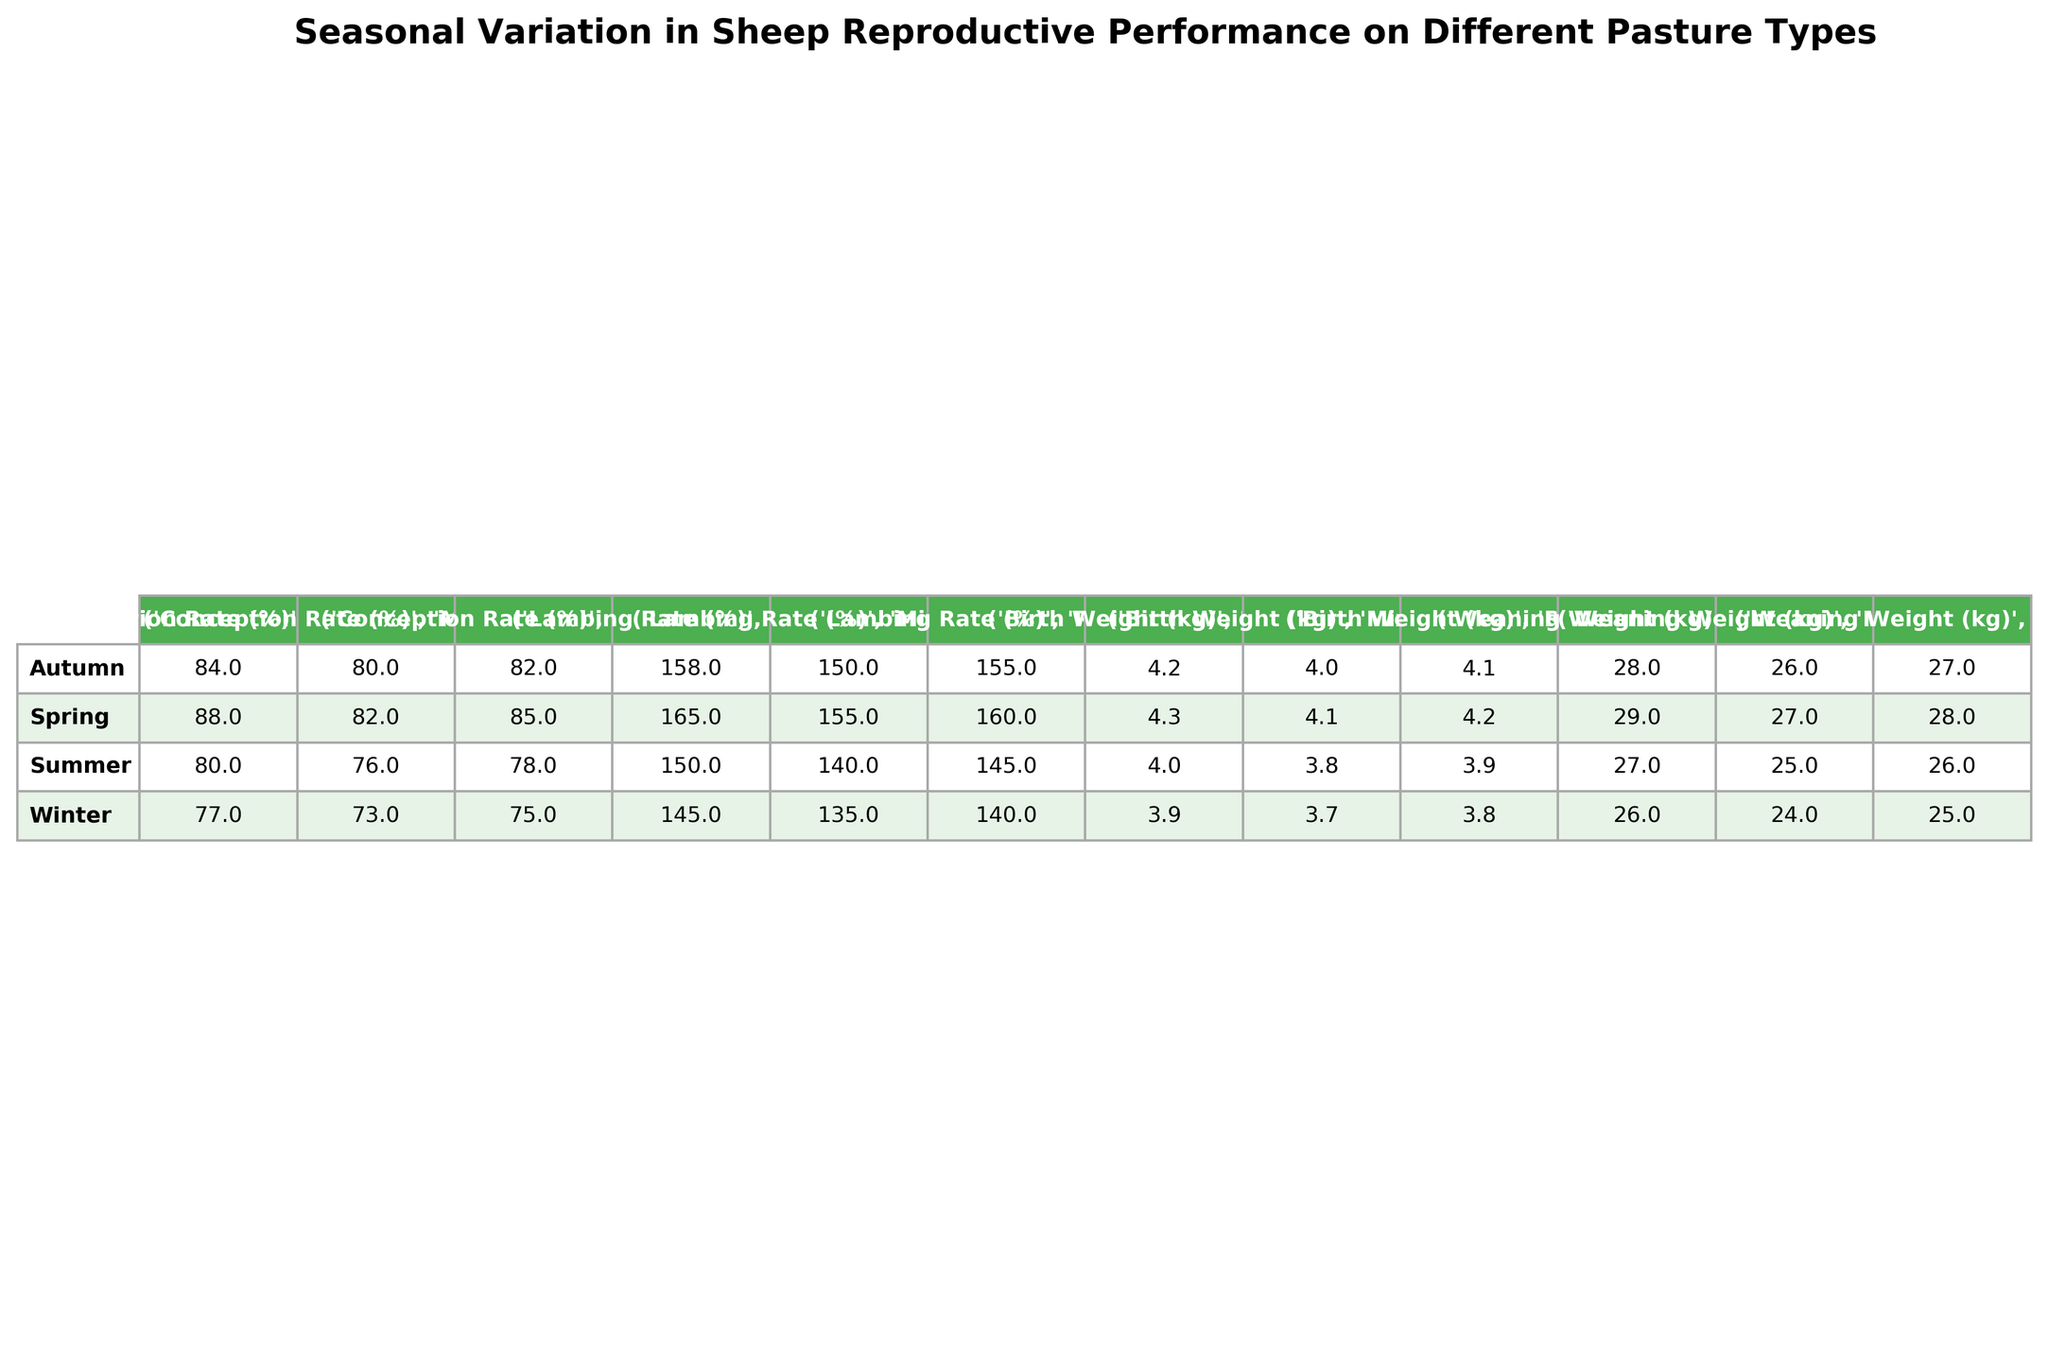What is the highest lambing rate recorded in Spring? Looking at the Spring data, the lambing rates for different pasture types are 160% for Ryegrass, 165% for Clover, and 155% for Mixed Herbs. The highest is 165%, which corresponds to Clover.
Answer: 165% Which pasture type has the lowest conception rate in Winter? In the Winter season, the conception rates for the pasture types are 75% for Ryegrass, 77% for Clover, and 73% for Mixed Herbs. The lowest is 73%, belonging to Mixed Herbs.
Answer: 73% What is the average weaning weight across all seasons for the Ryegrass pasture type? For Ryegrass, the weaning weights in each season are 28 kg in Spring, 26 kg in Summer, 27 kg in Autumn, and 25 kg in Winter. The average is (28 + 26 + 27 + 25) / 4 = 26.5 kg.
Answer: 26.5 kg Is it true that the conception rate is higher in Spring compared to Winter for Clover? Spring's conception rate for Clover is 88%, while Winter's is 77%. Since 88% is greater than 77%, the statement is true.
Answer: True How does the birth weight of lambs in Summer compare to that in Spring for Mixed Herbs? In Summer, the birth weight for Mixed Herbs is 3.8 kg, while in Spring it is 4.1 kg. Comparing these values shows that Summer's weight is less than Spring's.
Answer: Less What is the total change in lambing rate from Spring to Winter for Ryegrass? In Spring, the lambing rate for Ryegrass is 160%, and in Winter, it is 140%. The change is 160 - 140 = 20%. This indicates a decline in lambing rate.
Answer: 20% Which season has the highest overall conception rate and what is that percentage? Conception rates are 85% in Spring, 78% in Summer, 82% in Autumn, and 75% in Winter. The highest is 85%, which occurs in Spring.
Answer: 85% What is the difference in weaning weight between Spring and Autumn for Clover? The weaning weight for Clover in Spring is 29 kg and in Autumn is 28 kg. The difference is 29 - 28 = 1 kg.
Answer: 1 kg Which pasture type shows the most significant drop in lambing rate from Spring to Summer? For Spring, the lambing rate for Ryegrass is 160% and for Summer is 145%. The decrease is 160 - 145 = 15%. In comparison, Clover goes from 165% to 150% (15% decrease) and Mixed Herbs from 155% to 140% (15% decrease). Hence, the drop is the same across all pasture types, but Ryegrass shows the decrease first.
Answer: Ryegrass How do the weaning weights in Summer for Clover and Mixed Herbs compare? In Summer, Clover has a weaning weight of 27 kg and Mixed Herbs has a weaning weight of 25 kg. Clover is heavier than Mixed Herbs by 27 - 25 = 2 kg.
Answer: 2 kg 